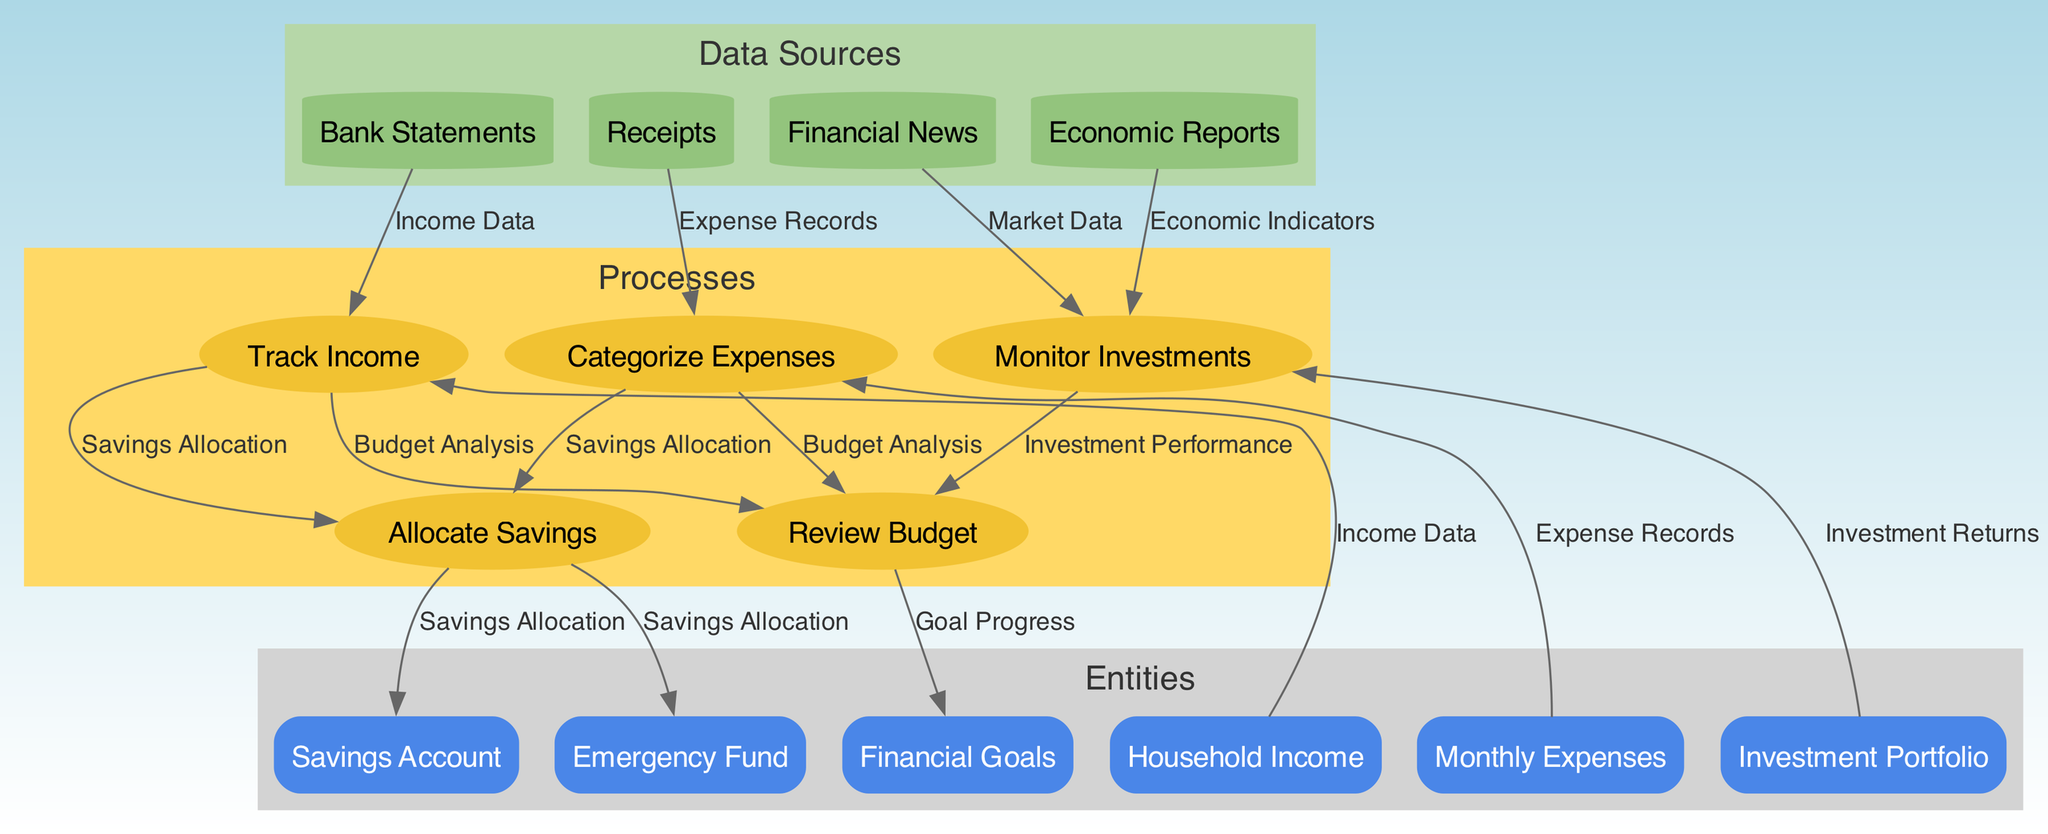What are the entities involved in the system? The diagram lists several entities including Household Income, Monthly Expenses, Savings Account, Emergency Fund, Investment Portfolio, and Financial Goals. Each of these represents a component in the household financial management process.
Answer: Household Income, Monthly Expenses, Savings Account, Emergency Fund, Investment Portfolio, Financial Goals How many processes are shown in the diagram? The diagram includes five processes: Track Income, Categorize Expenses, Allocate Savings, Monitor Investments, and Review Budget. Counting these provides the total number of distinct processes within the system.
Answer: 5 What data flows from Track Income to Allocate Savings? The data flow indicated from Track Income to Allocate Savings is labeled as Savings Allocation. This connection shows how the income tracking process feeds into the savings allocation step.
Answer: Savings Allocation Which data sources influence the Monitor Investments process? The Monitor Investments process is influenced by two data sources: Financial News and Economic Reports. This indicates that investment monitoring relies on external market data and economic indicators.
Answer: Financial News, Economic Reports What is the relationship between Categorize Expenses and Review Budget? The relationship is that Categorize Expenses sends Expense Records to the Review Budget process. This flow shows how expenses are categorized and then reviewed in the budgeting process.
Answer: Expense Records How many edges are connected to the Savings Account? There is one edge connected to the Savings Account, which is from the Allocate Savings process indicating the flow of savings allocation to the account.
Answer: 1 If Savings Allocation is increased, what would be the effect on Financial Goals? An increase in Savings Allocation would likely positively impact Financial Goals since the Review Budget process uses Savings Allocation data to assess progress towards these goals.
Answer: Positive impact What type of diagram is being used here? The diagram represents a Data Flow Diagram, which is specifically used to depict the flow of data among various entities and processes within a system.
Answer: Data Flow Diagram What is the purpose of the Review Budget process? The Review Budget process aims to analyze the overall financial situation, factoring in income tracking, categorized expenses, and investment performance to assess progress towards financial goals.
Answer: Analyze financial situation 